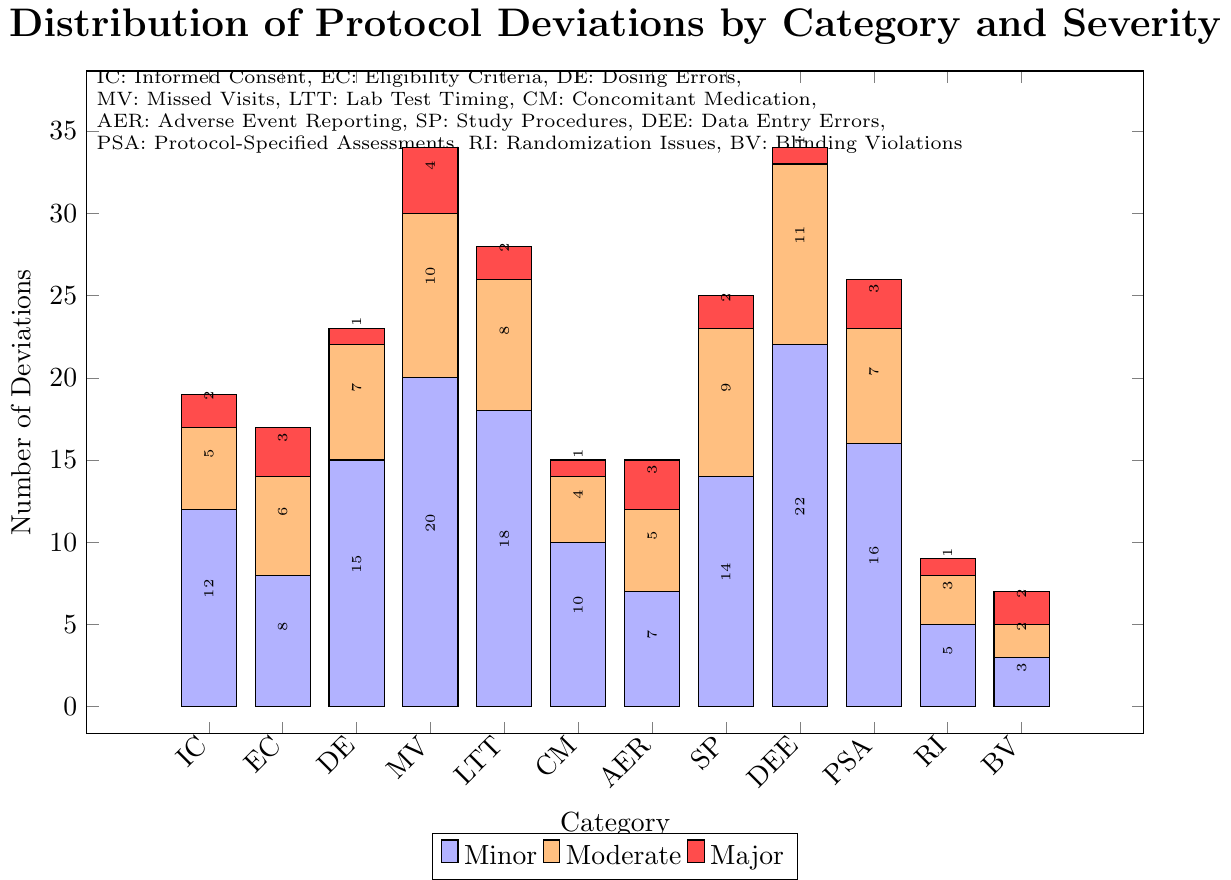What category has the highest total number of protocol deviations? To determine the category with the highest total number of protocol deviations, add up the values of Minor, Moderate, and Major deviations for each category, then compare the sums. For Data Entry Errors, for instance, the total is 22 (Minor) + 11 (Moderate) + 1 (Major) = 34. Comparing this with other categories, the highest total is seen in Data Entry Errors.
Answer: Data Entry Errors Which category has the lowest number of Major deviations? Look at the red bars (representing Major deviations) for each category and identify the one with the smallest value. Blinding Violations, Dosing Errors, Concomitant Medication, and Randomization Issues all have 1 Major deviation, but Blinding Violations also appears exceptional because it has the lowest overall deviations.
Answer: Dosing Errors (or any of the other categories with only 1 Major deviation) How many more Minor deviations are there than Major deviations in Missed Visits? For Missed Visits: Minor deviations = 20, Major deviations = 4. Calculate the difference: 20 - 4 = 16.
Answer: 16 Which category has more Minor deviations, Lab Test Timing or Informed Consent? And by how many? Compare the blue bars (representing Minor deviations) for Lab Test Timing and Informed Consent. Informed Consent has 12, and Lab Test Timing has 18. Calculate the difference: 18 - 12 = 6.
Answer: Lab Test Timing by 6 What is the average number of Moderate deviations across all categories? Sum up the number of Moderate deviations for all categories, then divide by the number of categories. Total Moderate deviations = 5 + 6 + 7 + 10 + 8 + 4 + 5 + 9 + 11 + 7 + 3 + 2 = 77. There are 12 categories, so the average = 77 / 12 = 6.42.
Answer: 6.42 Which categories have equal numbers of Moderate deviations? Compare the orange bars (representing Moderate deviations) for each category. Both Informed Consent and Adverse Event Reporting have 5 Moderate deviations, and both Eligibility Criteria and Protocol-Specified Assessments have 7 Moderate deviations.
Answer: Informed Consent and Adverse Event Reporting; Eligibility Criteria and Protocol-Specified Assessments Is the total number of deviations (Minor + Moderate + Major) for Study Procedures greater than the total for Concomitant Medication? Calculate the total deviations for both categories. Study Procedures = 14 (Minor) + 9 (Moderate) + 2 (Major) = 25. Concomitant Medication = 10 (Minor) + 4 (Moderate) + 1 (Major) = 15. Since 25 > 15, the total for Study Procedures is greater.
Answer: Yes What is the ratio of Minor to Major deviations for Randomization Issues? For Randomization Issues: Minor = 5, Major = 1. The ratio is calculated by dividing Minor deviations by Major deviations: 5 / 1.
Answer: 5:1 Which category has the largest difference between Minor and Moderate deviations, and what is that difference? Calculate the differences between Minor and Moderate deviations for each category and identify the largest. For example, Missed Visits: 20 (Minor) - 10 (Moderate) = 10. Data Entry Errors: 22 (Minor) - 11 (Moderate) = 11. The largest difference is for Data Entry Errors, with a difference of 11.
Answer: Data Entry Errors, 11 